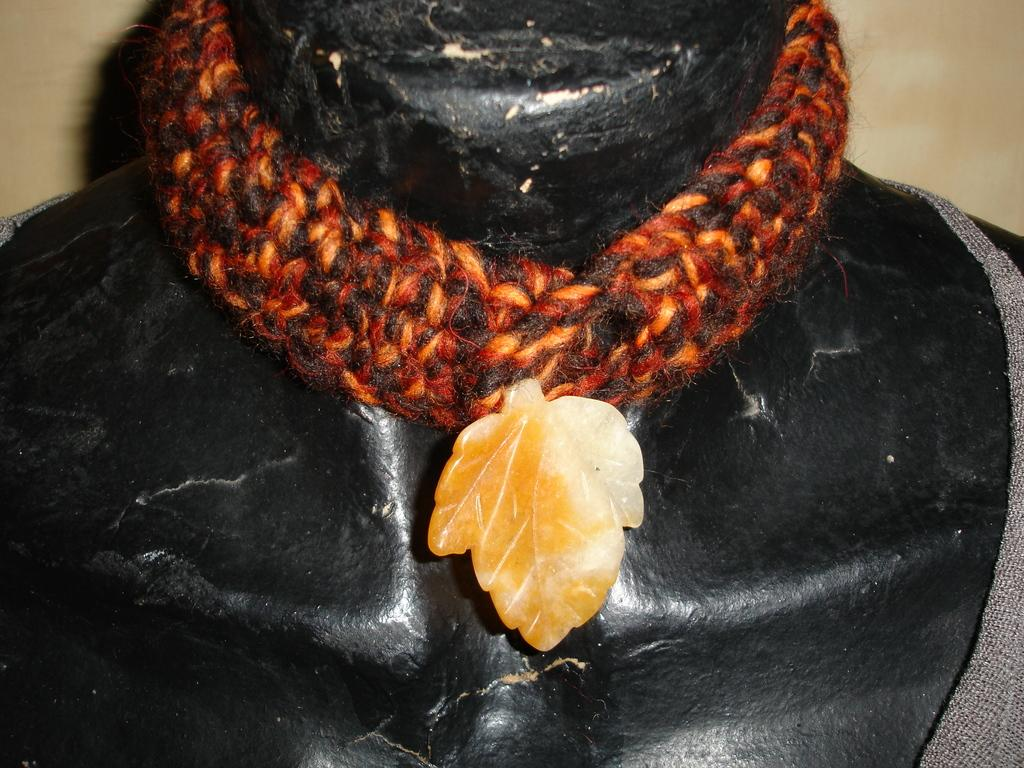What is the main subject of the image? The main subject of the image is a sculpture. Can you describe any specific features of the sculpture? Yes, the sculpture has a neckband. What type of patch can be seen on the sculpture in the image? There is no patch visible on the sculpture in the image. 